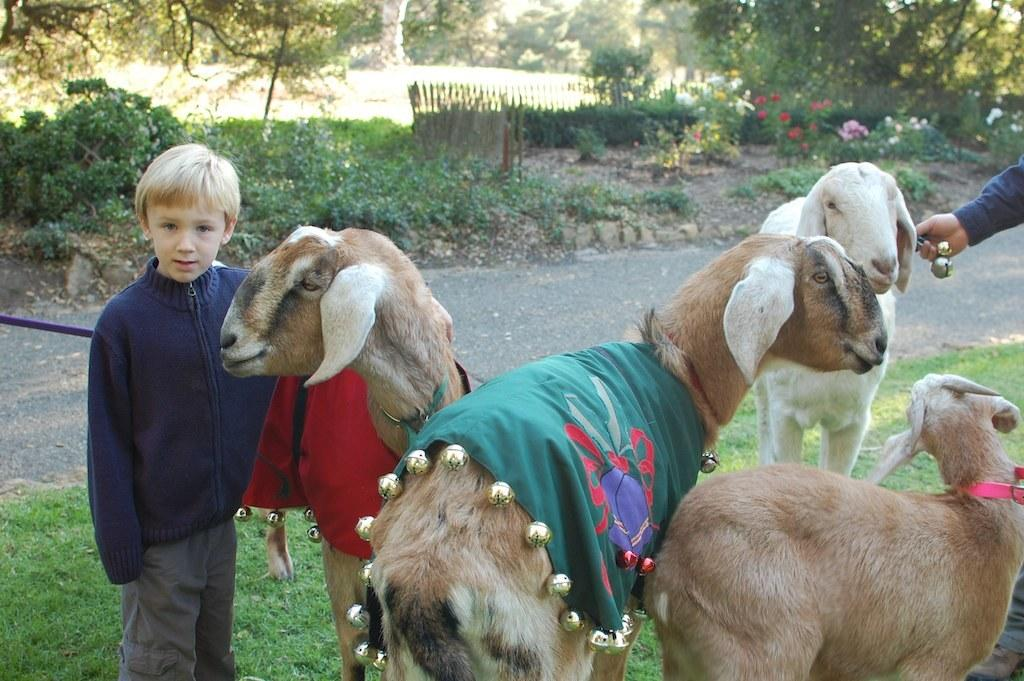What types of living organisms can be seen in the image? There are animals in the image. Can you describe the boy's appearance in the image? There is a boy wearing a blue jacket in the image. What type of terrain is visible in the image? There is grass visible in the image. What architectural feature can be seen in the image? There is a fence in the image. What type of vegetation is present in the image? There are trees in the image. What type of jail can be seen in the image? There is no jail present in the image. What type of farm animals can be seen in the image? The provided facts do not specify the type of animals in the image, so we cannot determine if they are farm animals. 